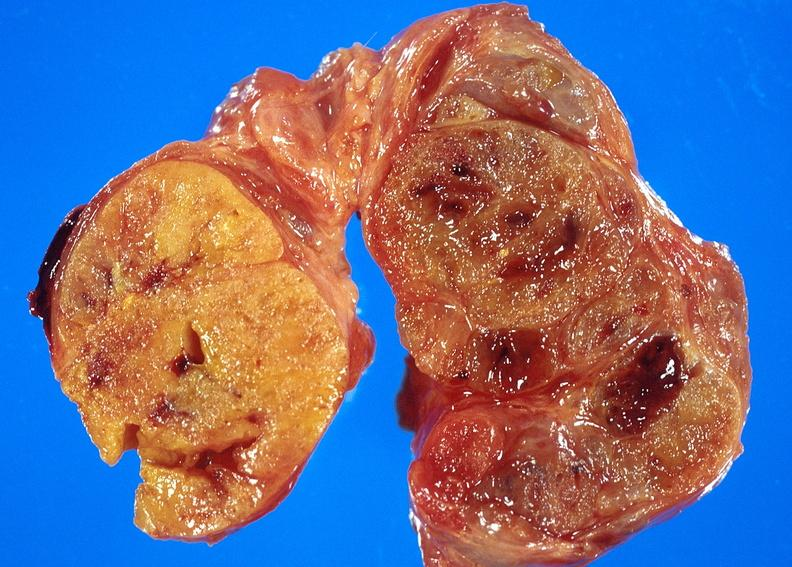does breast show thyroid, goiter?
Answer the question using a single word or phrase. No 